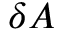<formula> <loc_0><loc_0><loc_500><loc_500>\delta A</formula> 